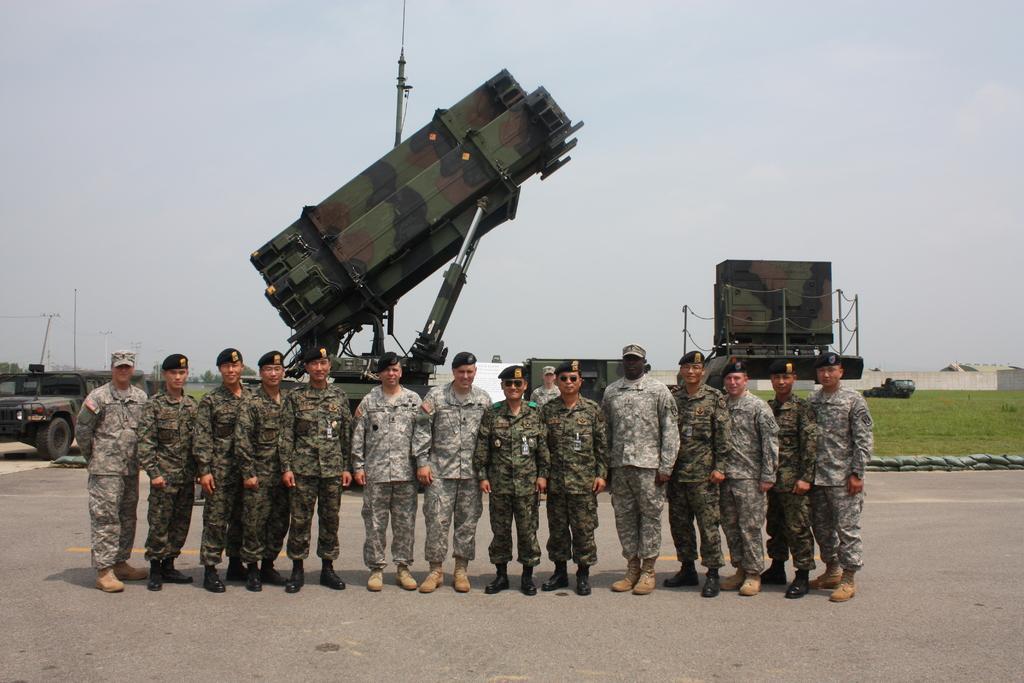Describe this image in one or two sentences. In this image I can see group of people standing and they are wearing military uniforms, background I can see few vehicles, trees and grass in green color and the sky is in white color. 